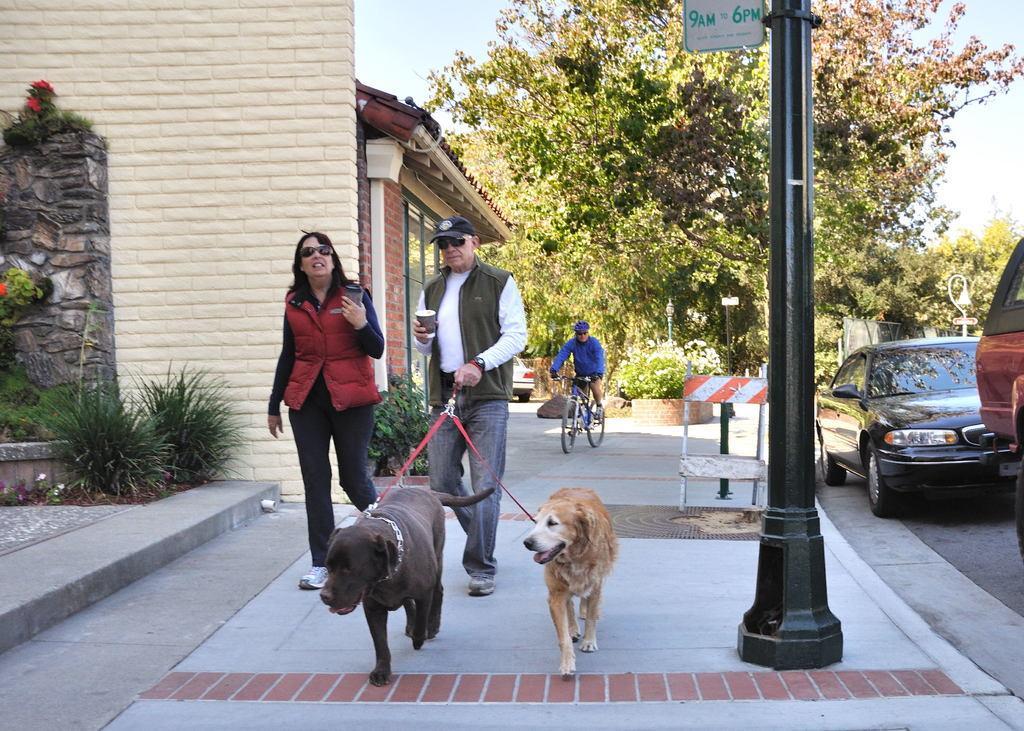In one or two sentences, can you explain what this image depicts? In the image we can see a man and a woman walking, they are wearing clothes, shoes, goggles and the man is wearing a cap and holding a glass in hand. On the other hand he is holding the ropes. We can see there are two dogs and there are vehicles on the road. Here we can see the barrier and there is a person riding on the bicycle. Here we can see the pole, house, grass, trees and the sky. 